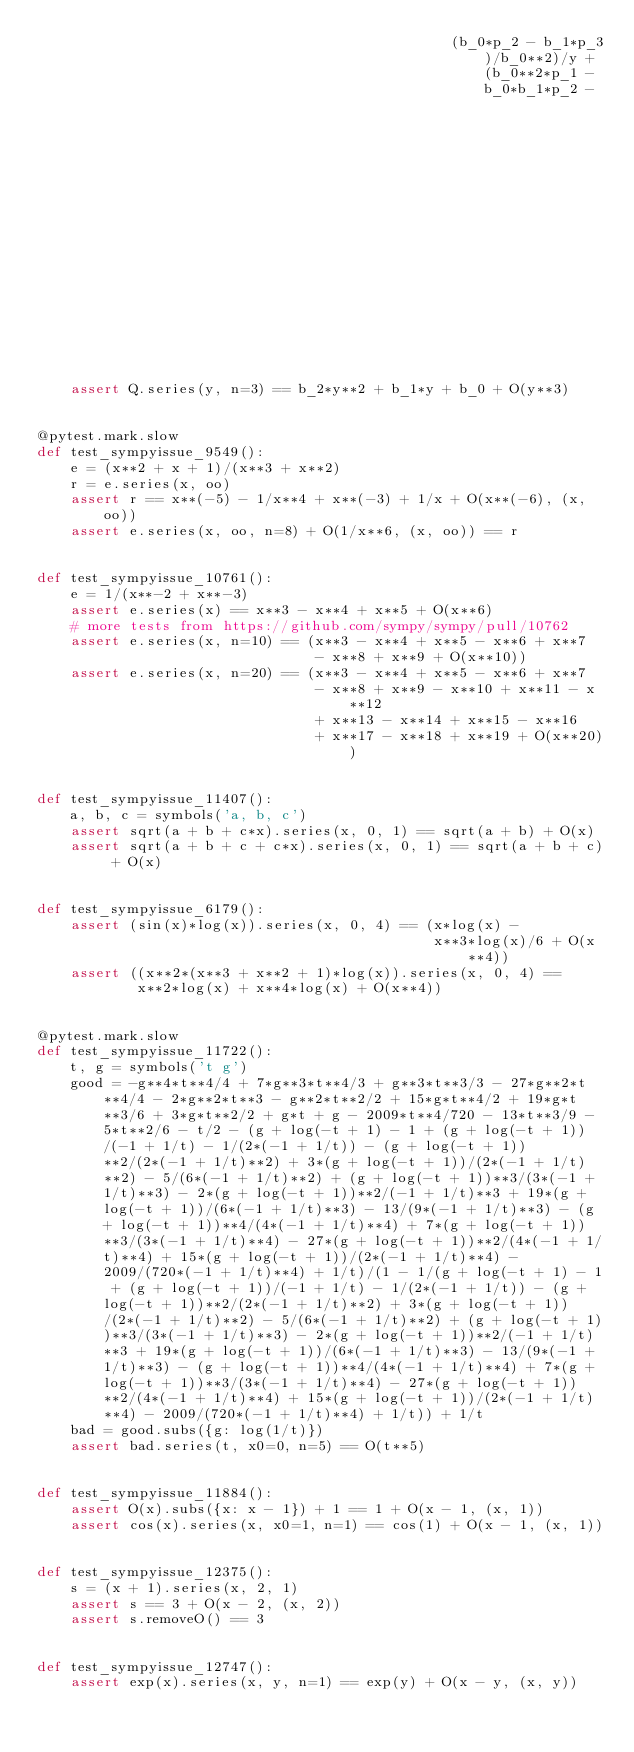Convert code to text. <code><loc_0><loc_0><loc_500><loc_500><_Python_>                                                 (b_0*p_2 - b_1*p_3)/b_0**2)/y + (b_0**2*p_1 - b_0*b_1*p_2 -
                                                                                  p_3*(b_0*b_2 - b_1**2))/b_0**3)/y)
    assert Q.series(y, n=3) == b_2*y**2 + b_1*y + b_0 + O(y**3)


@pytest.mark.slow
def test_sympyissue_9549():
    e = (x**2 + x + 1)/(x**3 + x**2)
    r = e.series(x, oo)
    assert r == x**(-5) - 1/x**4 + x**(-3) + 1/x + O(x**(-6), (x, oo))
    assert e.series(x, oo, n=8) + O(1/x**6, (x, oo)) == r


def test_sympyissue_10761():
    e = 1/(x**-2 + x**-3)
    assert e.series(x) == x**3 - x**4 + x**5 + O(x**6)
    # more tests from https://github.com/sympy/sympy/pull/10762
    assert e.series(x, n=10) == (x**3 - x**4 + x**5 - x**6 + x**7
                                 - x**8 + x**9 + O(x**10))
    assert e.series(x, n=20) == (x**3 - x**4 + x**5 - x**6 + x**7
                                 - x**8 + x**9 - x**10 + x**11 - x**12
                                 + x**13 - x**14 + x**15 - x**16
                                 + x**17 - x**18 + x**19 + O(x**20))


def test_sympyissue_11407():
    a, b, c = symbols('a, b, c')
    assert sqrt(a + b + c*x).series(x, 0, 1) == sqrt(a + b) + O(x)
    assert sqrt(a + b + c + c*x).series(x, 0, 1) == sqrt(a + b + c) + O(x)


def test_sympyissue_6179():
    assert (sin(x)*log(x)).series(x, 0, 4) == (x*log(x) -
                                               x**3*log(x)/6 + O(x**4))
    assert ((x**2*(x**3 + x**2 + 1)*log(x)).series(x, 0, 4) ==
            x**2*log(x) + x**4*log(x) + O(x**4))


@pytest.mark.slow
def test_sympyissue_11722():
    t, g = symbols('t g')
    good = -g**4*t**4/4 + 7*g**3*t**4/3 + g**3*t**3/3 - 27*g**2*t**4/4 - 2*g**2*t**3 - g**2*t**2/2 + 15*g*t**4/2 + 19*g*t**3/6 + 3*g*t**2/2 + g*t + g - 2009*t**4/720 - 13*t**3/9 - 5*t**2/6 - t/2 - (g + log(-t + 1) - 1 + (g + log(-t + 1))/(-1 + 1/t) - 1/(2*(-1 + 1/t)) - (g + log(-t + 1))**2/(2*(-1 + 1/t)**2) + 3*(g + log(-t + 1))/(2*(-1 + 1/t)**2) - 5/(6*(-1 + 1/t)**2) + (g + log(-t + 1))**3/(3*(-1 + 1/t)**3) - 2*(g + log(-t + 1))**2/(-1 + 1/t)**3 + 19*(g + log(-t + 1))/(6*(-1 + 1/t)**3) - 13/(9*(-1 + 1/t)**3) - (g + log(-t + 1))**4/(4*(-1 + 1/t)**4) + 7*(g + log(-t + 1))**3/(3*(-1 + 1/t)**4) - 27*(g + log(-t + 1))**2/(4*(-1 + 1/t)**4) + 15*(g + log(-t + 1))/(2*(-1 + 1/t)**4) - 2009/(720*(-1 + 1/t)**4) + 1/t)/(1 - 1/(g + log(-t + 1) - 1 + (g + log(-t + 1))/(-1 + 1/t) - 1/(2*(-1 + 1/t)) - (g + log(-t + 1))**2/(2*(-1 + 1/t)**2) + 3*(g + log(-t + 1))/(2*(-1 + 1/t)**2) - 5/(6*(-1 + 1/t)**2) + (g + log(-t + 1))**3/(3*(-1 + 1/t)**3) - 2*(g + log(-t + 1))**2/(-1 + 1/t)**3 + 19*(g + log(-t + 1))/(6*(-1 + 1/t)**3) - 13/(9*(-1 + 1/t)**3) - (g + log(-t + 1))**4/(4*(-1 + 1/t)**4) + 7*(g + log(-t + 1))**3/(3*(-1 + 1/t)**4) - 27*(g + log(-t + 1))**2/(4*(-1 + 1/t)**4) + 15*(g + log(-t + 1))/(2*(-1 + 1/t)**4) - 2009/(720*(-1 + 1/t)**4) + 1/t)) + 1/t
    bad = good.subs({g: log(1/t)})
    assert bad.series(t, x0=0, n=5) == O(t**5)


def test_sympyissue_11884():
    assert O(x).subs({x: x - 1}) + 1 == 1 + O(x - 1, (x, 1))
    assert cos(x).series(x, x0=1, n=1) == cos(1) + O(x - 1, (x, 1))


def test_sympyissue_12375():
    s = (x + 1).series(x, 2, 1)
    assert s == 3 + O(x - 2, (x, 2))
    assert s.removeO() == 3


def test_sympyissue_12747():
    assert exp(x).series(x, y, n=1) == exp(y) + O(x - y, (x, y))

</code> 